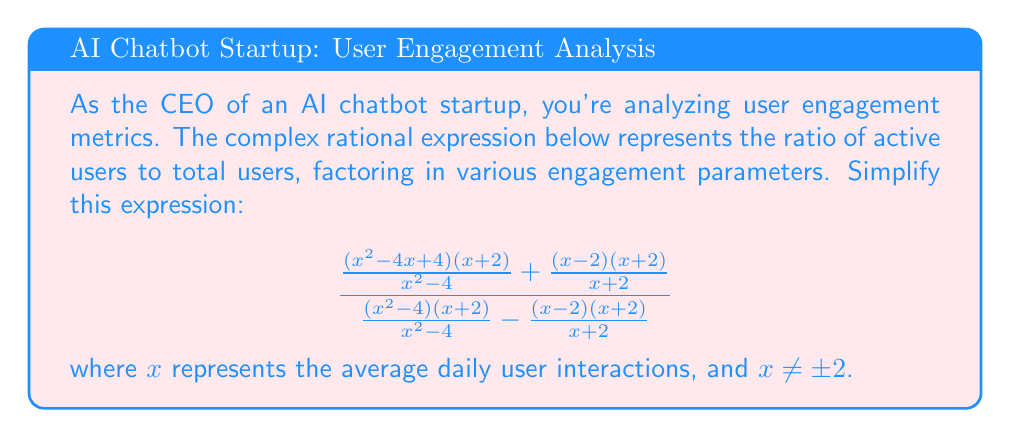Can you answer this question? Let's simplify this complex rational expression step by step:

1) First, let's simplify the numerator and denominator separately.

2) In the numerator:
   $$\frac{(x^2 - 4x + 4)(x + 2)}{x^2 - 4} + \frac{(x - 2)(x + 2)}{x + 2}$$
   
   The second term simplifies to $(x - 2)$, so we have:
   $$\frac{(x^2 - 4x + 4)(x + 2)}{x^2 - 4} + (x - 2)$$

3) In the denominator:
   $$\frac{(x^2 - 4)(x + 2)}{x^2 - 4} - \frac{(x - 2)(x + 2)}{x + 2}$$
   
   The first term simplifies to $(x + 2)$, and the second to $(x - 2)$, so we have:
   $$(x + 2) - (x - 2) = 4$$

4) Now our expression looks like:
   $$\frac{\frac{(x^2 - 4x + 4)(x + 2)}{x^2 - 4} + (x - 2)}{4}$$

5) Let's focus on simplifying $\frac{(x^2 - 4x + 4)(x + 2)}{x^2 - 4}$:
   
   $$\frac{(x^2 - 4x + 4)(x + 2)}{x^2 - 4} = \frac{(x - 2)^2(x + 2)}{(x - 2)(x + 2)} = x - 2$$

6) Substituting this back into our expression:
   $$\frac{(x - 2) + (x - 2)}{4} = \frac{2(x - 2)}{4} = \frac{x - 2}{2}$$

Thus, the simplified expression is $\frac{x - 2}{2}$.
Answer: $\frac{x - 2}{2}$ 